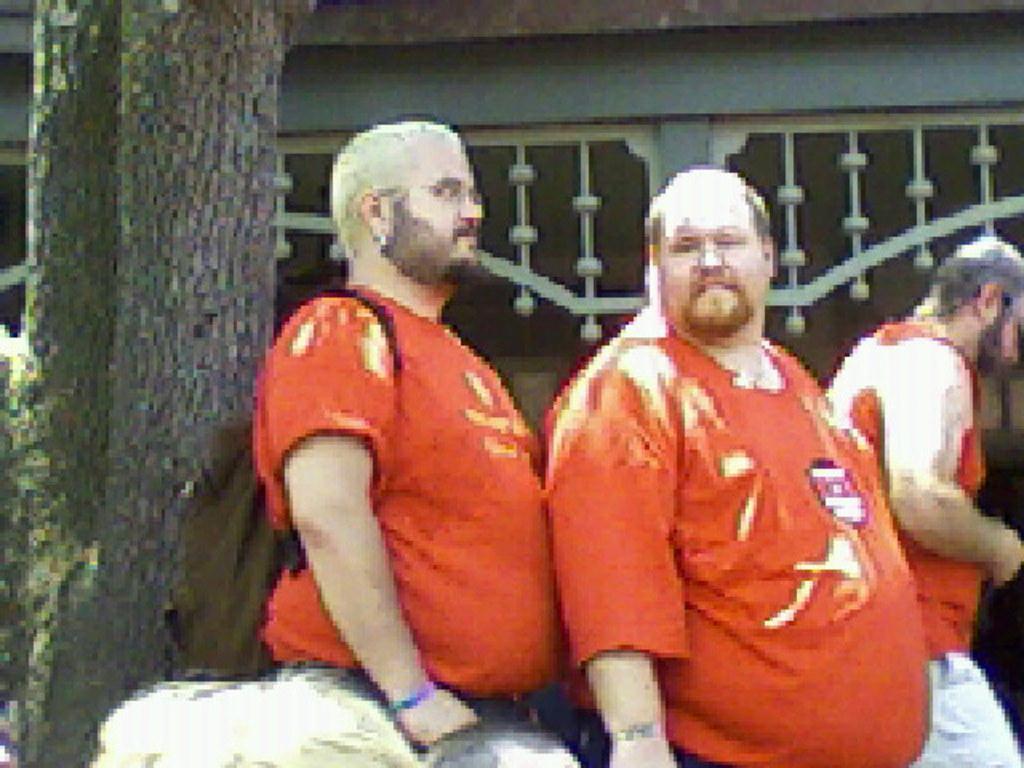Can you describe this image briefly? In this image I can see three persons, tree trunk and a building. This image looks like an edited photo. 